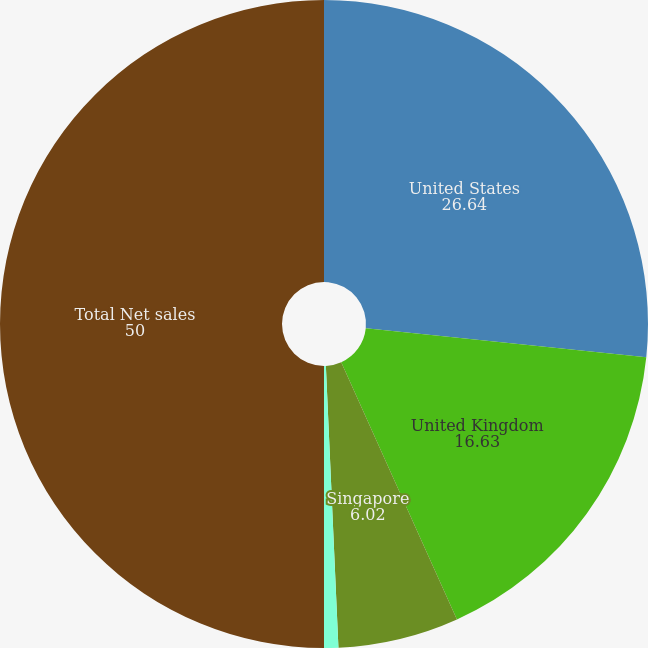Convert chart. <chart><loc_0><loc_0><loc_500><loc_500><pie_chart><fcel>United States<fcel>United Kingdom<fcel>Singapore<fcel>Other<fcel>Total Net sales<nl><fcel>26.64%<fcel>16.63%<fcel>6.02%<fcel>0.71%<fcel>50.0%<nl></chart> 